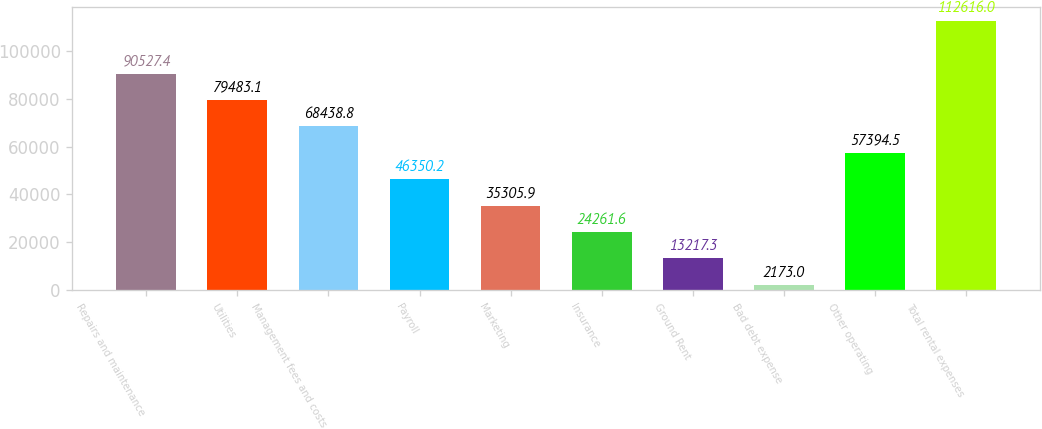Convert chart to OTSL. <chart><loc_0><loc_0><loc_500><loc_500><bar_chart><fcel>Repairs and maintenance<fcel>Utilities<fcel>Management fees and costs<fcel>Payroll<fcel>Marketing<fcel>Insurance<fcel>Ground Rent<fcel>Bad debt expense<fcel>Other operating<fcel>Total rental expenses<nl><fcel>90527.4<fcel>79483.1<fcel>68438.8<fcel>46350.2<fcel>35305.9<fcel>24261.6<fcel>13217.3<fcel>2173<fcel>57394.5<fcel>112616<nl></chart> 